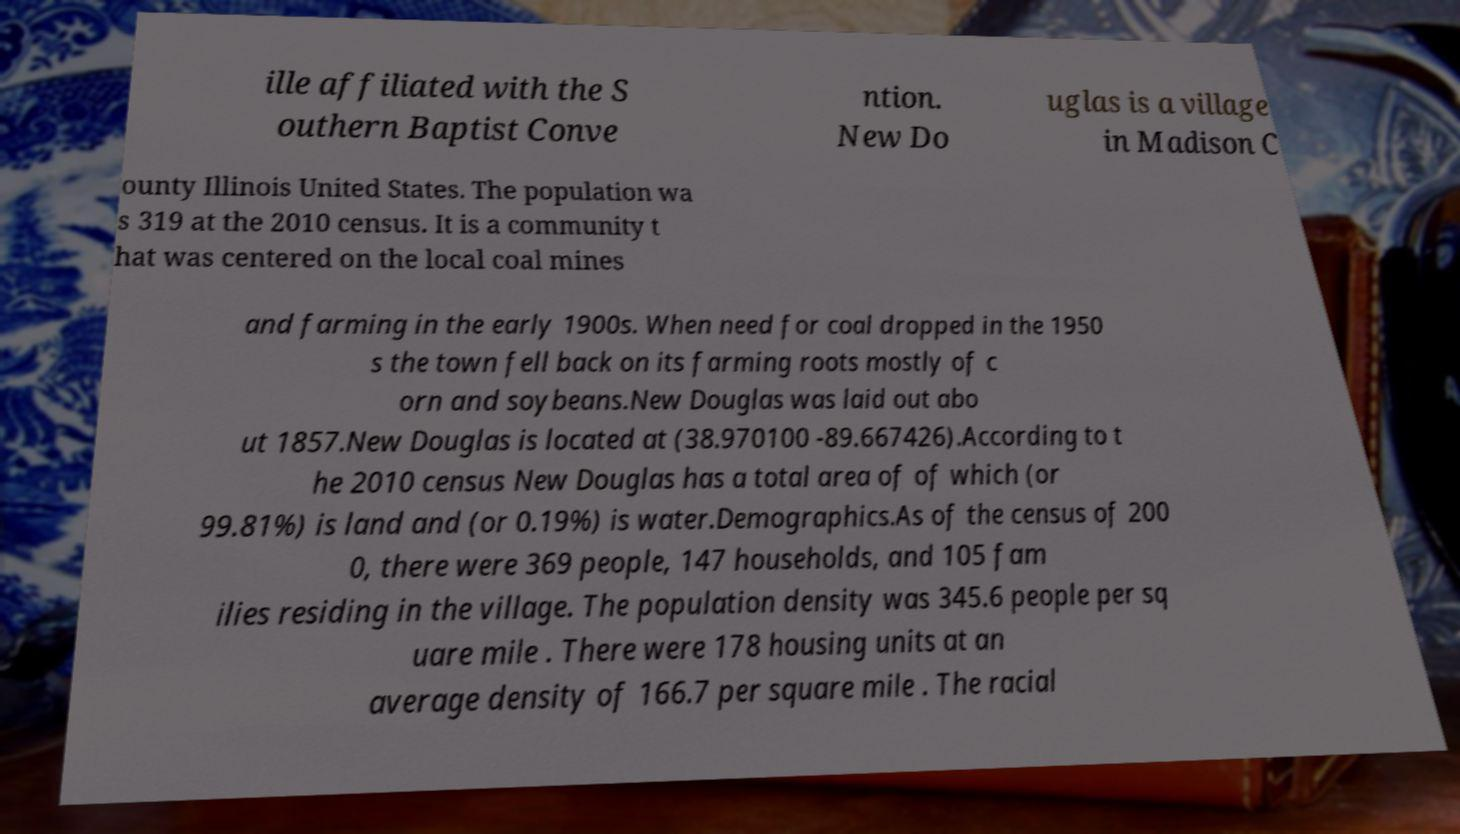There's text embedded in this image that I need extracted. Can you transcribe it verbatim? ille affiliated with the S outhern Baptist Conve ntion. New Do uglas is a village in Madison C ounty Illinois United States. The population wa s 319 at the 2010 census. It is a community t hat was centered on the local coal mines and farming in the early 1900s. When need for coal dropped in the 1950 s the town fell back on its farming roots mostly of c orn and soybeans.New Douglas was laid out abo ut 1857.New Douglas is located at (38.970100 -89.667426).According to t he 2010 census New Douglas has a total area of of which (or 99.81%) is land and (or 0.19%) is water.Demographics.As of the census of 200 0, there were 369 people, 147 households, and 105 fam ilies residing in the village. The population density was 345.6 people per sq uare mile . There were 178 housing units at an average density of 166.7 per square mile . The racial 